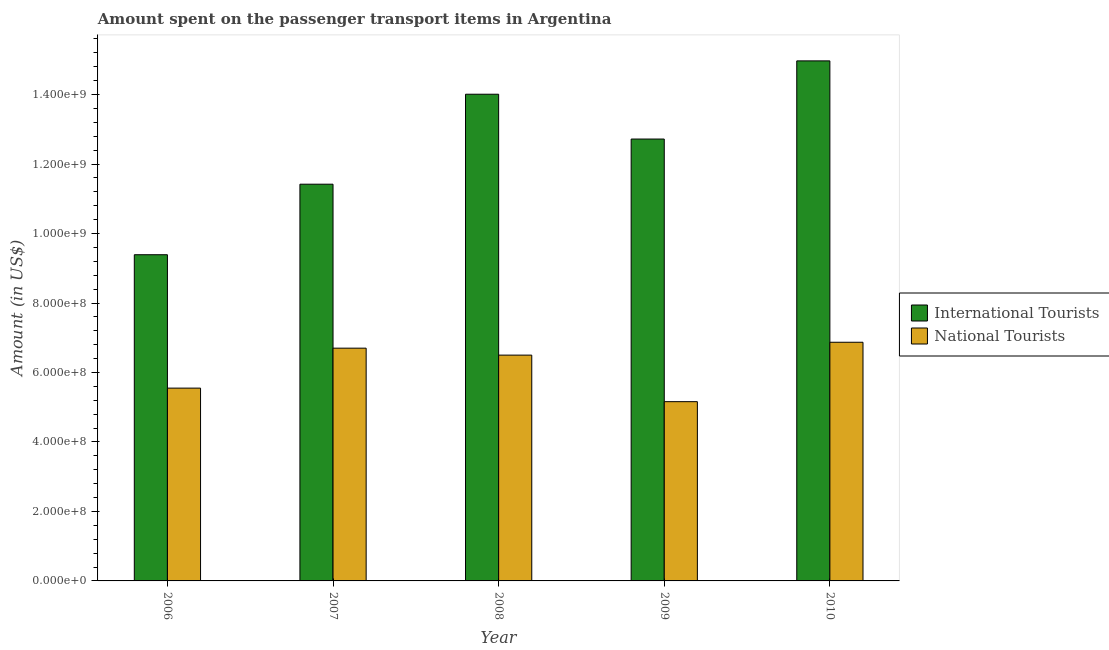How many groups of bars are there?
Offer a very short reply. 5. Are the number of bars per tick equal to the number of legend labels?
Offer a very short reply. Yes. Are the number of bars on each tick of the X-axis equal?
Provide a succinct answer. Yes. How many bars are there on the 2nd tick from the left?
Your response must be concise. 2. How many bars are there on the 5th tick from the right?
Ensure brevity in your answer.  2. What is the label of the 4th group of bars from the left?
Provide a short and direct response. 2009. What is the amount spent on transport items of international tourists in 2009?
Your answer should be very brief. 1.27e+09. Across all years, what is the maximum amount spent on transport items of international tourists?
Offer a very short reply. 1.50e+09. Across all years, what is the minimum amount spent on transport items of national tourists?
Your answer should be very brief. 5.16e+08. What is the total amount spent on transport items of national tourists in the graph?
Offer a very short reply. 3.08e+09. What is the difference between the amount spent on transport items of international tourists in 2008 and that in 2010?
Offer a terse response. -9.60e+07. What is the difference between the amount spent on transport items of national tourists in 2010 and the amount spent on transport items of international tourists in 2007?
Your answer should be very brief. 1.70e+07. What is the average amount spent on transport items of international tourists per year?
Make the answer very short. 1.25e+09. In how many years, is the amount spent on transport items of international tourists greater than 640000000 US$?
Ensure brevity in your answer.  5. What is the ratio of the amount spent on transport items of international tourists in 2006 to that in 2007?
Offer a terse response. 0.82. Is the amount spent on transport items of international tourists in 2009 less than that in 2010?
Your answer should be compact. Yes. What is the difference between the highest and the second highest amount spent on transport items of national tourists?
Your answer should be very brief. 1.70e+07. What is the difference between the highest and the lowest amount spent on transport items of national tourists?
Offer a very short reply. 1.71e+08. In how many years, is the amount spent on transport items of national tourists greater than the average amount spent on transport items of national tourists taken over all years?
Your response must be concise. 3. Is the sum of the amount spent on transport items of international tourists in 2006 and 2009 greater than the maximum amount spent on transport items of national tourists across all years?
Provide a succinct answer. Yes. What does the 2nd bar from the left in 2010 represents?
Give a very brief answer. National Tourists. What does the 1st bar from the right in 2007 represents?
Provide a succinct answer. National Tourists. Are all the bars in the graph horizontal?
Provide a succinct answer. No. How many years are there in the graph?
Provide a short and direct response. 5. Does the graph contain any zero values?
Give a very brief answer. No. Does the graph contain grids?
Your answer should be very brief. No. Where does the legend appear in the graph?
Provide a succinct answer. Center right. How many legend labels are there?
Make the answer very short. 2. What is the title of the graph?
Keep it short and to the point. Amount spent on the passenger transport items in Argentina. Does "Chemicals" appear as one of the legend labels in the graph?
Your answer should be very brief. No. What is the label or title of the X-axis?
Provide a short and direct response. Year. What is the Amount (in US$) of International Tourists in 2006?
Give a very brief answer. 9.39e+08. What is the Amount (in US$) in National Tourists in 2006?
Provide a short and direct response. 5.55e+08. What is the Amount (in US$) in International Tourists in 2007?
Offer a terse response. 1.14e+09. What is the Amount (in US$) of National Tourists in 2007?
Give a very brief answer. 6.70e+08. What is the Amount (in US$) in International Tourists in 2008?
Ensure brevity in your answer.  1.40e+09. What is the Amount (in US$) in National Tourists in 2008?
Offer a very short reply. 6.50e+08. What is the Amount (in US$) in International Tourists in 2009?
Your response must be concise. 1.27e+09. What is the Amount (in US$) in National Tourists in 2009?
Provide a succinct answer. 5.16e+08. What is the Amount (in US$) of International Tourists in 2010?
Give a very brief answer. 1.50e+09. What is the Amount (in US$) of National Tourists in 2010?
Offer a very short reply. 6.87e+08. Across all years, what is the maximum Amount (in US$) in International Tourists?
Ensure brevity in your answer.  1.50e+09. Across all years, what is the maximum Amount (in US$) of National Tourists?
Your answer should be very brief. 6.87e+08. Across all years, what is the minimum Amount (in US$) of International Tourists?
Provide a short and direct response. 9.39e+08. Across all years, what is the minimum Amount (in US$) of National Tourists?
Offer a terse response. 5.16e+08. What is the total Amount (in US$) of International Tourists in the graph?
Your answer should be compact. 6.25e+09. What is the total Amount (in US$) of National Tourists in the graph?
Offer a very short reply. 3.08e+09. What is the difference between the Amount (in US$) in International Tourists in 2006 and that in 2007?
Give a very brief answer. -2.03e+08. What is the difference between the Amount (in US$) of National Tourists in 2006 and that in 2007?
Provide a succinct answer. -1.15e+08. What is the difference between the Amount (in US$) of International Tourists in 2006 and that in 2008?
Provide a succinct answer. -4.62e+08. What is the difference between the Amount (in US$) of National Tourists in 2006 and that in 2008?
Make the answer very short. -9.50e+07. What is the difference between the Amount (in US$) of International Tourists in 2006 and that in 2009?
Your answer should be compact. -3.33e+08. What is the difference between the Amount (in US$) in National Tourists in 2006 and that in 2009?
Give a very brief answer. 3.90e+07. What is the difference between the Amount (in US$) in International Tourists in 2006 and that in 2010?
Provide a short and direct response. -5.58e+08. What is the difference between the Amount (in US$) in National Tourists in 2006 and that in 2010?
Your response must be concise. -1.32e+08. What is the difference between the Amount (in US$) of International Tourists in 2007 and that in 2008?
Give a very brief answer. -2.59e+08. What is the difference between the Amount (in US$) of International Tourists in 2007 and that in 2009?
Ensure brevity in your answer.  -1.30e+08. What is the difference between the Amount (in US$) in National Tourists in 2007 and that in 2009?
Keep it short and to the point. 1.54e+08. What is the difference between the Amount (in US$) in International Tourists in 2007 and that in 2010?
Provide a succinct answer. -3.55e+08. What is the difference between the Amount (in US$) in National Tourists in 2007 and that in 2010?
Ensure brevity in your answer.  -1.70e+07. What is the difference between the Amount (in US$) of International Tourists in 2008 and that in 2009?
Provide a succinct answer. 1.29e+08. What is the difference between the Amount (in US$) of National Tourists in 2008 and that in 2009?
Your response must be concise. 1.34e+08. What is the difference between the Amount (in US$) in International Tourists in 2008 and that in 2010?
Your answer should be compact. -9.60e+07. What is the difference between the Amount (in US$) in National Tourists in 2008 and that in 2010?
Your answer should be very brief. -3.70e+07. What is the difference between the Amount (in US$) of International Tourists in 2009 and that in 2010?
Give a very brief answer. -2.25e+08. What is the difference between the Amount (in US$) of National Tourists in 2009 and that in 2010?
Ensure brevity in your answer.  -1.71e+08. What is the difference between the Amount (in US$) of International Tourists in 2006 and the Amount (in US$) of National Tourists in 2007?
Offer a very short reply. 2.69e+08. What is the difference between the Amount (in US$) of International Tourists in 2006 and the Amount (in US$) of National Tourists in 2008?
Provide a succinct answer. 2.89e+08. What is the difference between the Amount (in US$) in International Tourists in 2006 and the Amount (in US$) in National Tourists in 2009?
Keep it short and to the point. 4.23e+08. What is the difference between the Amount (in US$) in International Tourists in 2006 and the Amount (in US$) in National Tourists in 2010?
Provide a short and direct response. 2.52e+08. What is the difference between the Amount (in US$) of International Tourists in 2007 and the Amount (in US$) of National Tourists in 2008?
Provide a short and direct response. 4.92e+08. What is the difference between the Amount (in US$) of International Tourists in 2007 and the Amount (in US$) of National Tourists in 2009?
Keep it short and to the point. 6.26e+08. What is the difference between the Amount (in US$) in International Tourists in 2007 and the Amount (in US$) in National Tourists in 2010?
Ensure brevity in your answer.  4.55e+08. What is the difference between the Amount (in US$) of International Tourists in 2008 and the Amount (in US$) of National Tourists in 2009?
Offer a terse response. 8.85e+08. What is the difference between the Amount (in US$) of International Tourists in 2008 and the Amount (in US$) of National Tourists in 2010?
Give a very brief answer. 7.14e+08. What is the difference between the Amount (in US$) of International Tourists in 2009 and the Amount (in US$) of National Tourists in 2010?
Give a very brief answer. 5.85e+08. What is the average Amount (in US$) of International Tourists per year?
Offer a very short reply. 1.25e+09. What is the average Amount (in US$) in National Tourists per year?
Give a very brief answer. 6.16e+08. In the year 2006, what is the difference between the Amount (in US$) of International Tourists and Amount (in US$) of National Tourists?
Ensure brevity in your answer.  3.84e+08. In the year 2007, what is the difference between the Amount (in US$) in International Tourists and Amount (in US$) in National Tourists?
Provide a succinct answer. 4.72e+08. In the year 2008, what is the difference between the Amount (in US$) of International Tourists and Amount (in US$) of National Tourists?
Provide a short and direct response. 7.51e+08. In the year 2009, what is the difference between the Amount (in US$) in International Tourists and Amount (in US$) in National Tourists?
Offer a terse response. 7.56e+08. In the year 2010, what is the difference between the Amount (in US$) in International Tourists and Amount (in US$) in National Tourists?
Offer a very short reply. 8.10e+08. What is the ratio of the Amount (in US$) in International Tourists in 2006 to that in 2007?
Provide a short and direct response. 0.82. What is the ratio of the Amount (in US$) in National Tourists in 2006 to that in 2007?
Provide a short and direct response. 0.83. What is the ratio of the Amount (in US$) of International Tourists in 2006 to that in 2008?
Provide a short and direct response. 0.67. What is the ratio of the Amount (in US$) in National Tourists in 2006 to that in 2008?
Give a very brief answer. 0.85. What is the ratio of the Amount (in US$) of International Tourists in 2006 to that in 2009?
Make the answer very short. 0.74. What is the ratio of the Amount (in US$) of National Tourists in 2006 to that in 2009?
Offer a very short reply. 1.08. What is the ratio of the Amount (in US$) in International Tourists in 2006 to that in 2010?
Offer a terse response. 0.63. What is the ratio of the Amount (in US$) of National Tourists in 2006 to that in 2010?
Offer a terse response. 0.81. What is the ratio of the Amount (in US$) in International Tourists in 2007 to that in 2008?
Provide a succinct answer. 0.82. What is the ratio of the Amount (in US$) in National Tourists in 2007 to that in 2008?
Your response must be concise. 1.03. What is the ratio of the Amount (in US$) of International Tourists in 2007 to that in 2009?
Provide a short and direct response. 0.9. What is the ratio of the Amount (in US$) in National Tourists in 2007 to that in 2009?
Offer a very short reply. 1.3. What is the ratio of the Amount (in US$) in International Tourists in 2007 to that in 2010?
Keep it short and to the point. 0.76. What is the ratio of the Amount (in US$) of National Tourists in 2007 to that in 2010?
Make the answer very short. 0.98. What is the ratio of the Amount (in US$) in International Tourists in 2008 to that in 2009?
Your answer should be very brief. 1.1. What is the ratio of the Amount (in US$) in National Tourists in 2008 to that in 2009?
Give a very brief answer. 1.26. What is the ratio of the Amount (in US$) of International Tourists in 2008 to that in 2010?
Offer a very short reply. 0.94. What is the ratio of the Amount (in US$) in National Tourists in 2008 to that in 2010?
Your response must be concise. 0.95. What is the ratio of the Amount (in US$) in International Tourists in 2009 to that in 2010?
Keep it short and to the point. 0.85. What is the ratio of the Amount (in US$) of National Tourists in 2009 to that in 2010?
Provide a short and direct response. 0.75. What is the difference between the highest and the second highest Amount (in US$) in International Tourists?
Keep it short and to the point. 9.60e+07. What is the difference between the highest and the second highest Amount (in US$) in National Tourists?
Provide a succinct answer. 1.70e+07. What is the difference between the highest and the lowest Amount (in US$) of International Tourists?
Make the answer very short. 5.58e+08. What is the difference between the highest and the lowest Amount (in US$) in National Tourists?
Your answer should be very brief. 1.71e+08. 